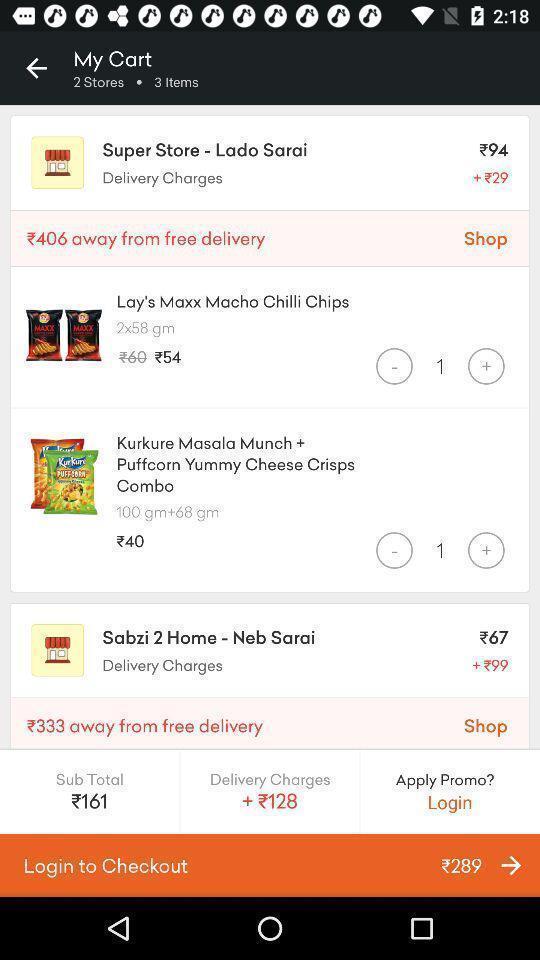Tell me about the visual elements in this screen capture. Screen showing page of an shopping application. 